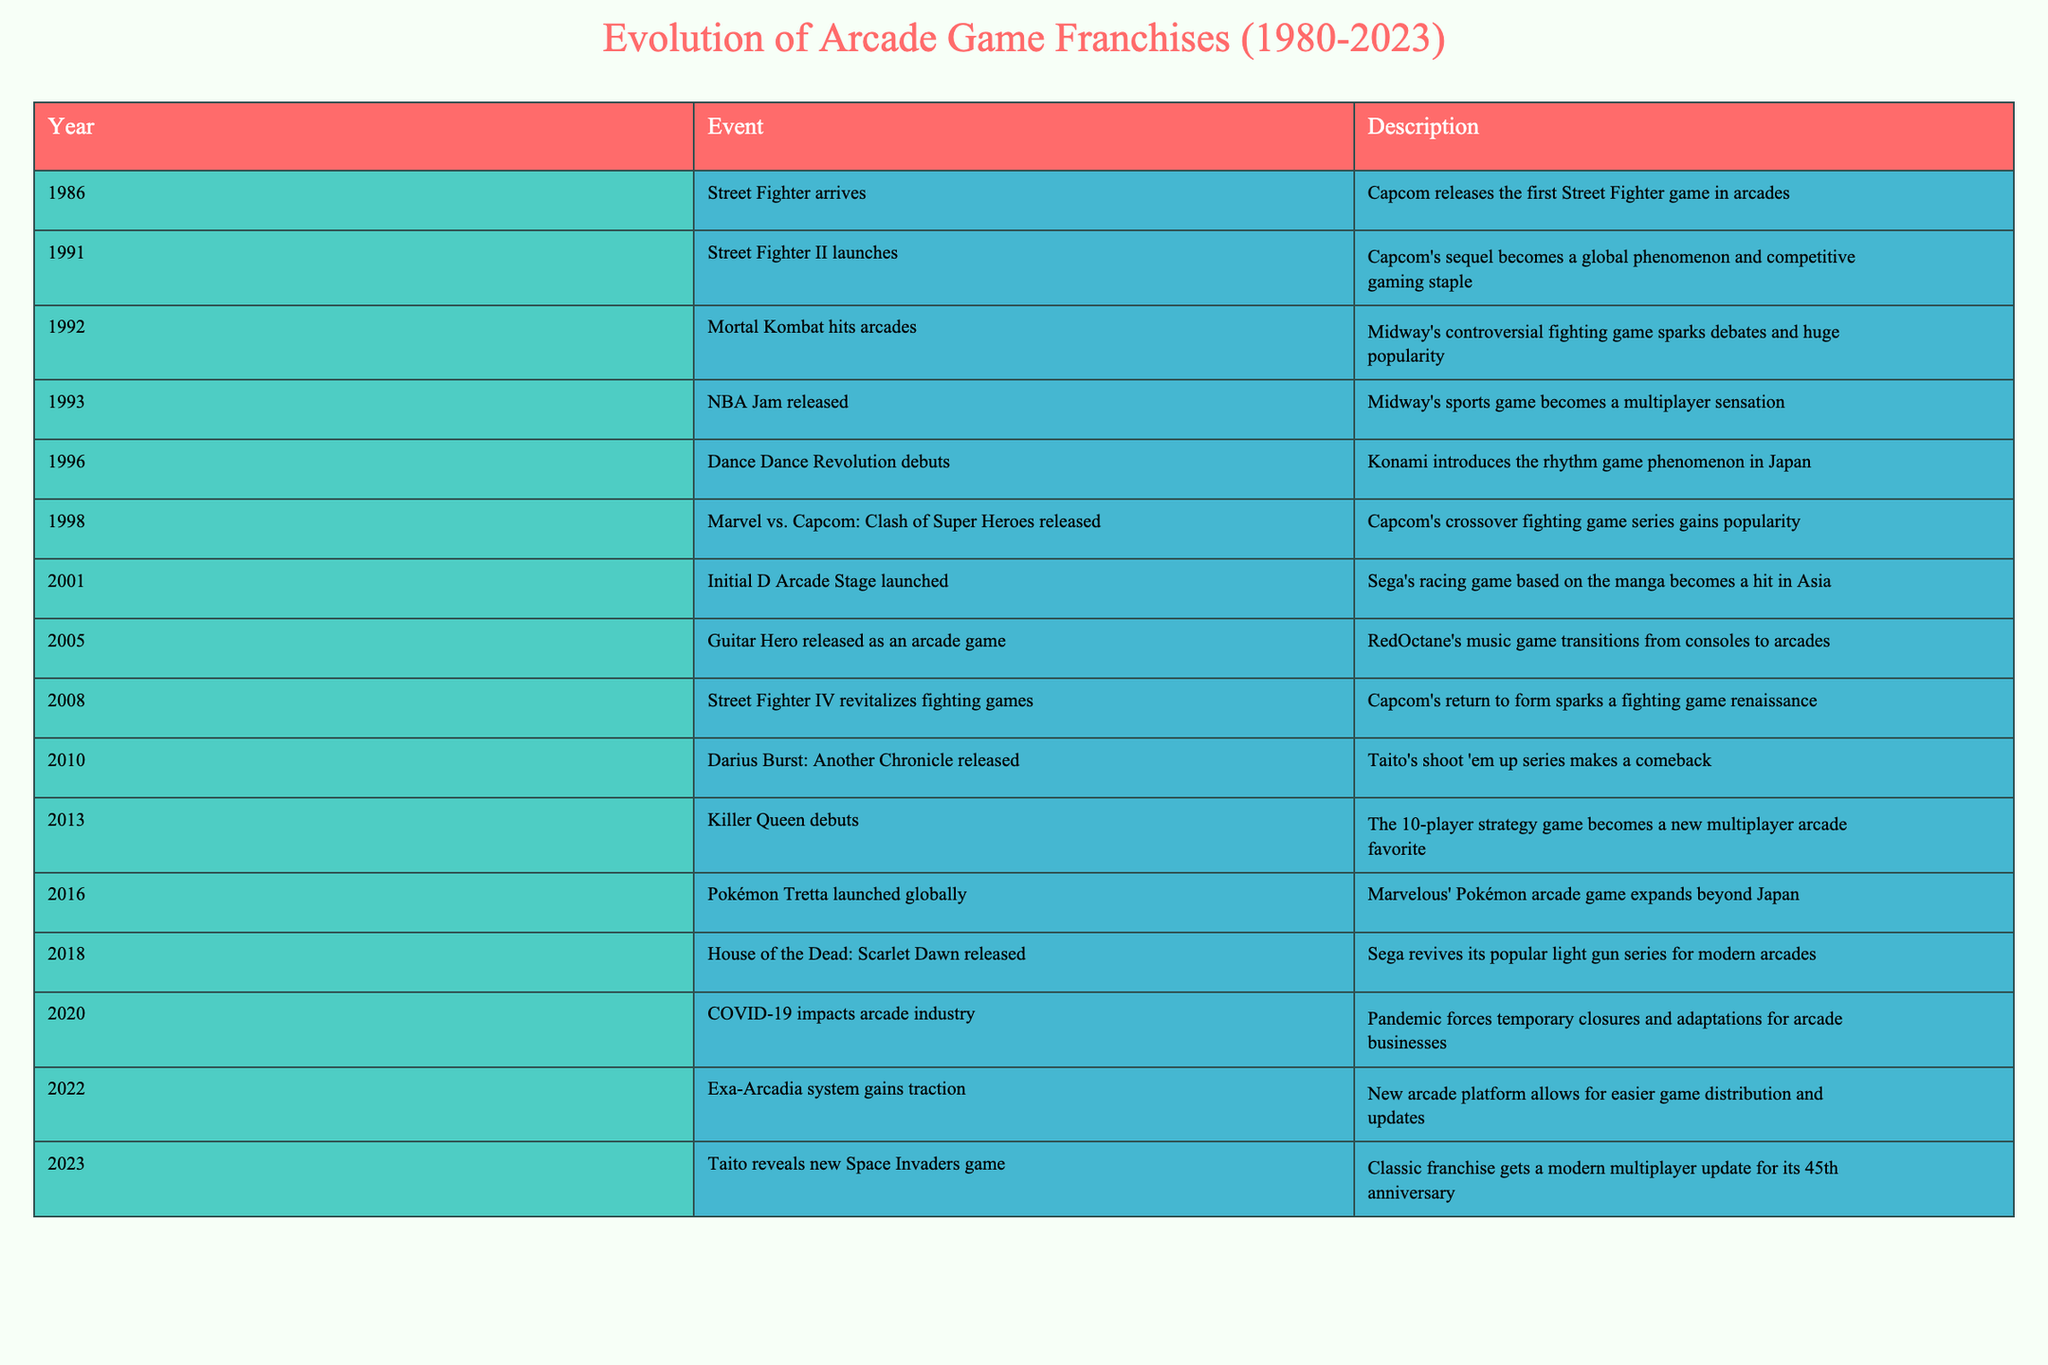What year did Street Fighter II launch? Street Fighter II is listed in the table under the year 1991. This can be found by referring to the row that mentions the event "Street Fighter II launches."
Answer: 1991 What franchise did Mortal Kombat belong to? The event "Mortal Kombat hits arcades" indicates that it is from Midway, which is historically known for the Mortal Kombat franchise. This can be verified in the description for the year 1992.
Answer: Mortal Kombat Which event happened first, the release of Dance Dance Revolution or NBA Jam? By checking the years in the table, Dance Dance Revolution debuted in 1996, while NBA Jam was released in 1993. Since 1993 is earlier than 1996, NBA Jam happened first.
Answer: NBA Jam How many years passed between the release of the first Street Fighter and Street Fighter IV? The first Street Fighter was released in 1986 and Street Fighter IV in 2008. Calculating the difference: 2008 - 1986 = 22 years.
Answer: 22 years Did the arcade industry face any disruptions in 2020? The event listed for 2020 clearly states "COVID-19 impacts arcade industry," showing that there were significant disruptions due to the pandemic.
Answer: Yes In what year was the Exa-Arcadia system released? The table shows that the Exa-Arcadia system gained traction in 2022. This information can be found directly in the given row of events.
Answer: 2022 Which game series saw a resurgence in 2013? The event description for the year 2013 indicates "Killer Queen debuts," which can be interpreted as a new multiplayer arcade favorite, signaling a resurgence in arcade gaming popularity.
Answer: Killer Queen What was the trend in fighting games between the release of Street Fighter II and Street Fighter IV? Looking at the timeline, Street Fighter II launched in 1991, and Street Fighter IV revitalized fighting games in 2008, indicating a trend of renewed interest and revival of fighting games over those 17 years.
Answer: Revival How many fighting games are listed in the table? By reviewing each entry under the "Event" column, there are four notable fighting games: Street Fighter, Street Fighter II, Mortal Kombat, and Street Fighter IV. Thus, there are four fighting games listed.
Answer: Four 